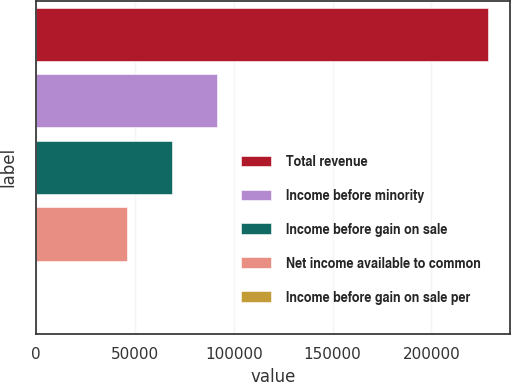Convert chart to OTSL. <chart><loc_0><loc_0><loc_500><loc_500><bar_chart><fcel>Total revenue<fcel>Income before minority<fcel>Income before gain on sale<fcel>Net income available to common<fcel>Income before gain on sale per<nl><fcel>228527<fcel>91411.1<fcel>68558.5<fcel>45705.8<fcel>0.52<nl></chart> 